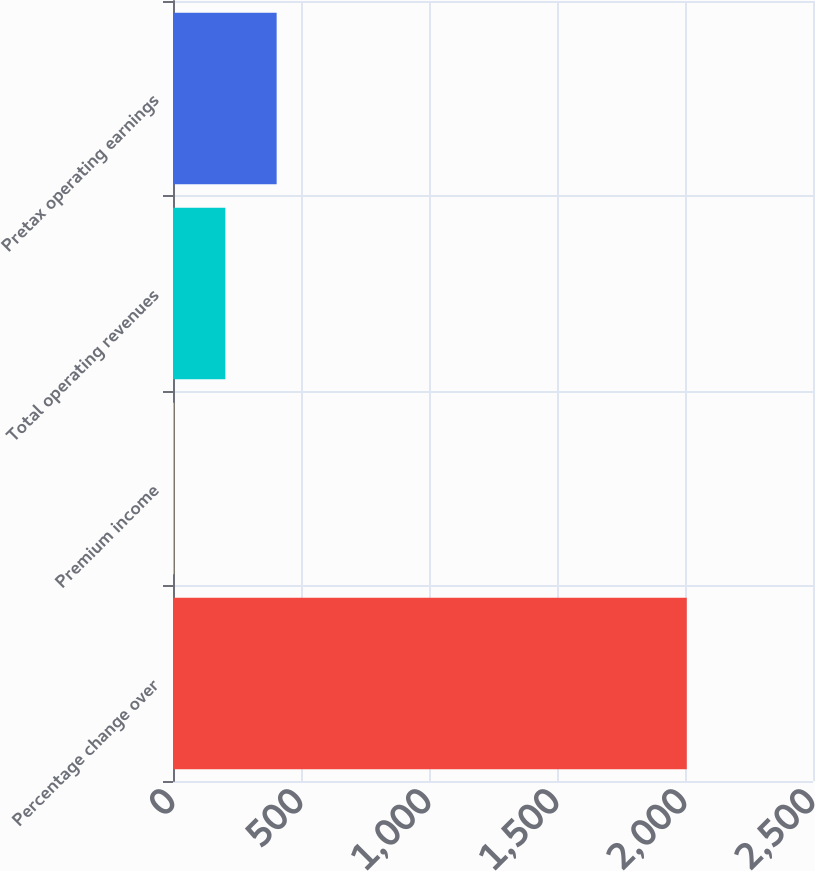Convert chart. <chart><loc_0><loc_0><loc_500><loc_500><bar_chart><fcel>Percentage change over<fcel>Premium income<fcel>Total operating revenues<fcel>Pretax operating earnings<nl><fcel>2007<fcel>4.3<fcel>204.57<fcel>404.84<nl></chart> 